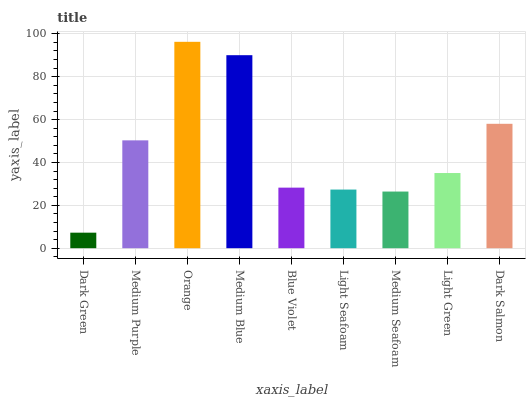Is Dark Green the minimum?
Answer yes or no. Yes. Is Orange the maximum?
Answer yes or no. Yes. Is Medium Purple the minimum?
Answer yes or no. No. Is Medium Purple the maximum?
Answer yes or no. No. Is Medium Purple greater than Dark Green?
Answer yes or no. Yes. Is Dark Green less than Medium Purple?
Answer yes or no. Yes. Is Dark Green greater than Medium Purple?
Answer yes or no. No. Is Medium Purple less than Dark Green?
Answer yes or no. No. Is Light Green the high median?
Answer yes or no. Yes. Is Light Green the low median?
Answer yes or no. Yes. Is Dark Green the high median?
Answer yes or no. No. Is Light Seafoam the low median?
Answer yes or no. No. 